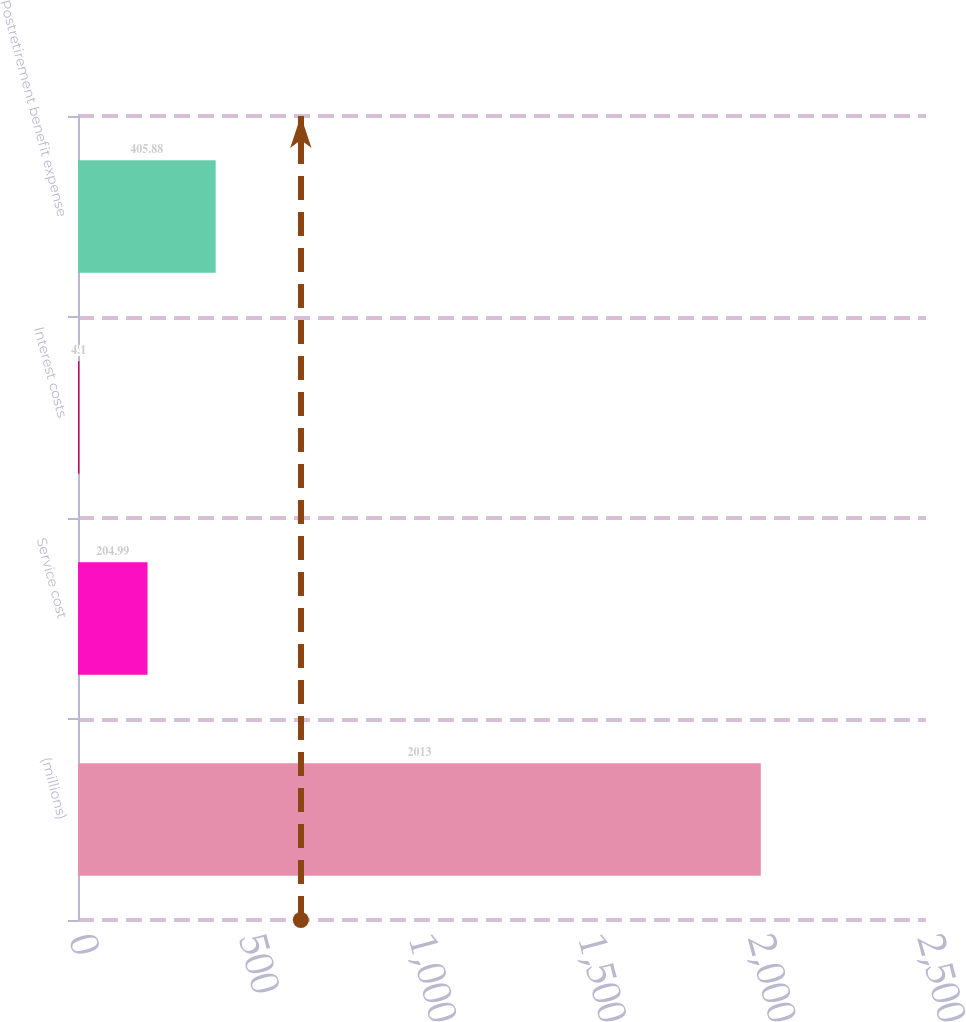<chart> <loc_0><loc_0><loc_500><loc_500><bar_chart><fcel>(millions)<fcel>Service cost<fcel>Interest costs<fcel>Postretirement benefit expense<nl><fcel>2013<fcel>204.99<fcel>4.1<fcel>405.88<nl></chart> 